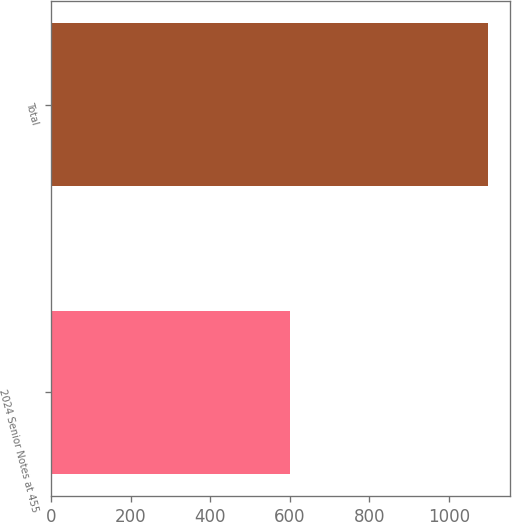<chart> <loc_0><loc_0><loc_500><loc_500><bar_chart><fcel>2024 Senior Notes at 455<fcel>Total<nl><fcel>600<fcel>1099<nl></chart> 